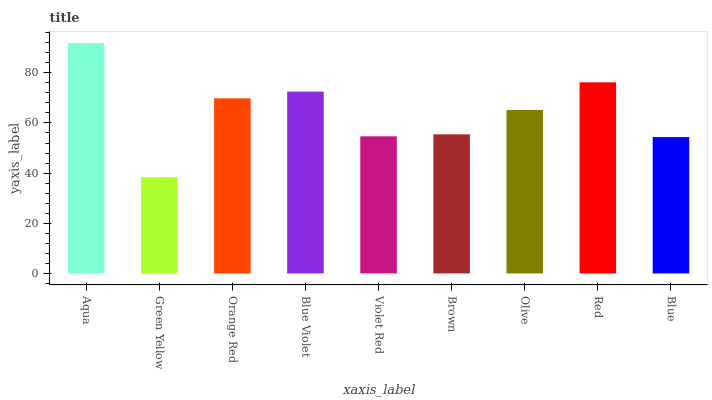Is Green Yellow the minimum?
Answer yes or no. Yes. Is Aqua the maximum?
Answer yes or no. Yes. Is Orange Red the minimum?
Answer yes or no. No. Is Orange Red the maximum?
Answer yes or no. No. Is Orange Red greater than Green Yellow?
Answer yes or no. Yes. Is Green Yellow less than Orange Red?
Answer yes or no. Yes. Is Green Yellow greater than Orange Red?
Answer yes or no. No. Is Orange Red less than Green Yellow?
Answer yes or no. No. Is Olive the high median?
Answer yes or no. Yes. Is Olive the low median?
Answer yes or no. Yes. Is Red the high median?
Answer yes or no. No. Is Red the low median?
Answer yes or no. No. 